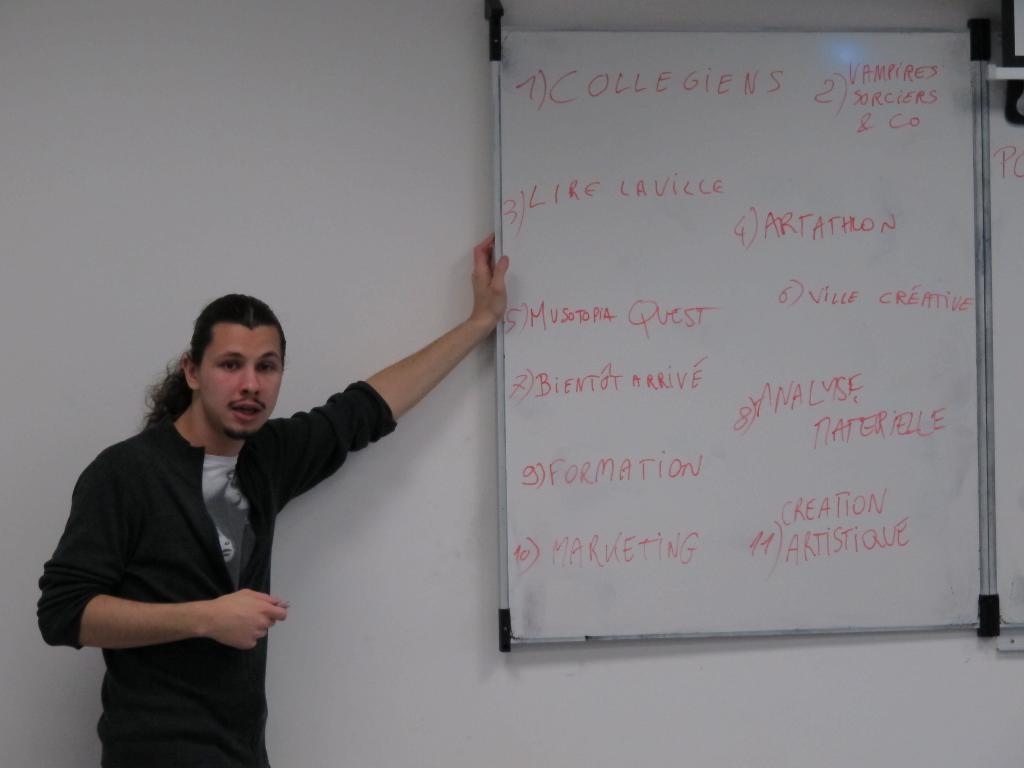What does the first statement say?
Offer a very short reply. Collegiens. What does the third item say?
Keep it short and to the point. Lire laville. 